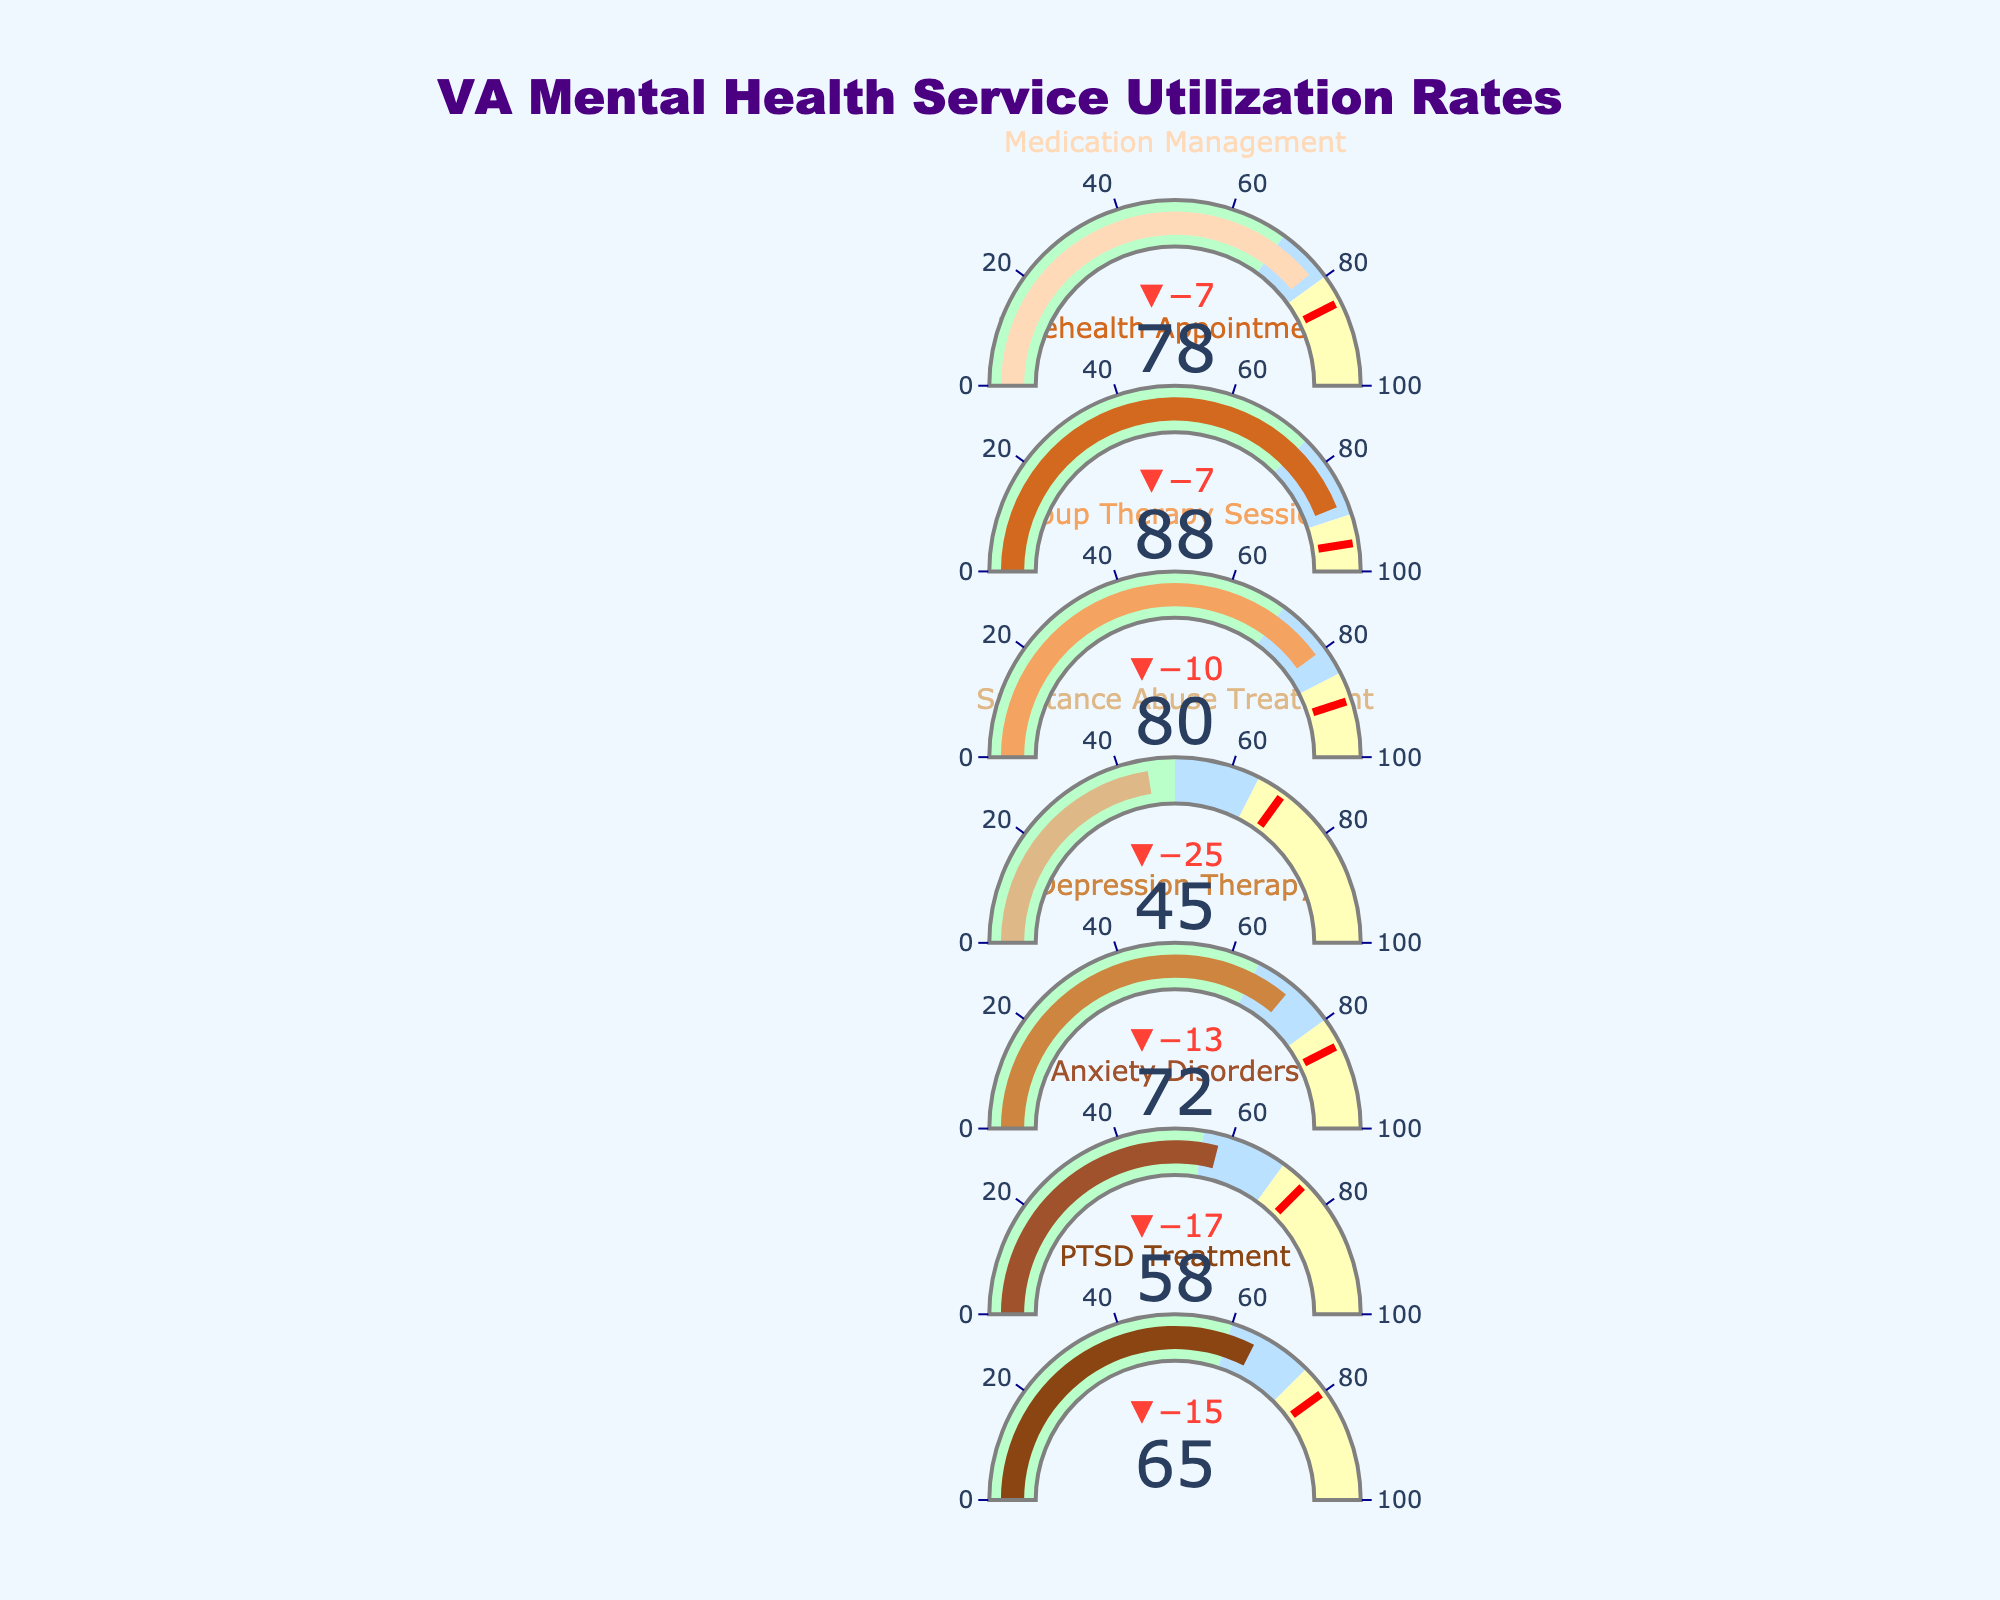What is the title of the figure? The title is located at the top and reads, "VA Mental Health Service Utilization Rates."
Answer: VA Mental Health Service Utilization Rates How many categories of mental health services are displayed in the figure? The figure lists each category along the vertical axis (left side). Count the total entries to determine the number of categories.
Answer: 7 What color represents the 'PTSD Treatment' bar? Look at the color of the bar under the 'PTSD Treatment' title on the left side of the chart.
Answer: Brown Which service surpassed its target utilization rate? Compare the actual values with the target values for each category. Telehealth Appointments has an actual value (88) greater than its target value (95).
Answer: None Which service is closest to meeting its target utilization rate? Calculate the absolute difference between the actual and target values for each category, and identify the smallest difference.
Answer: Medication Management What is the combined actual utilization rate for Anxiety Disorders and Depression Therapy? Add the actual values for Anxiety Disorders (58) and Depression Therapy (72): 58 + 72 = 130.
Answer: 130 What is the difference between the Satisfactory range and the Target value for Substance Abuse Treatment? Subtract the Satisfactory range end (50) from the Target value (70) for Substance Abuse Treatment: 70 - 50 = 20.
Answer: 20 Which service has the lowest actual utilization rate, and what is its value? Look for the smallest number in the 'Actual' column in the figure to find the service with the lowest utilization rate.
Answer: Substance Abuse Treatment, 45 How much higher is the actual utilization rate of Group Therapy Sessions compared to Anxiety Disorders? Subtract the actual value of Anxiety Disorders (58) from the actual value of Group Therapy Sessions (80): 80 - 58 = 22.
Answer: 22 In how many categories does the actual utilization rate fall into the 'Good' range? Compare each actual value against the 'Good' ranges specified in the figure and count the number of categories that fall into the 'Good' range.
Answer: 1 